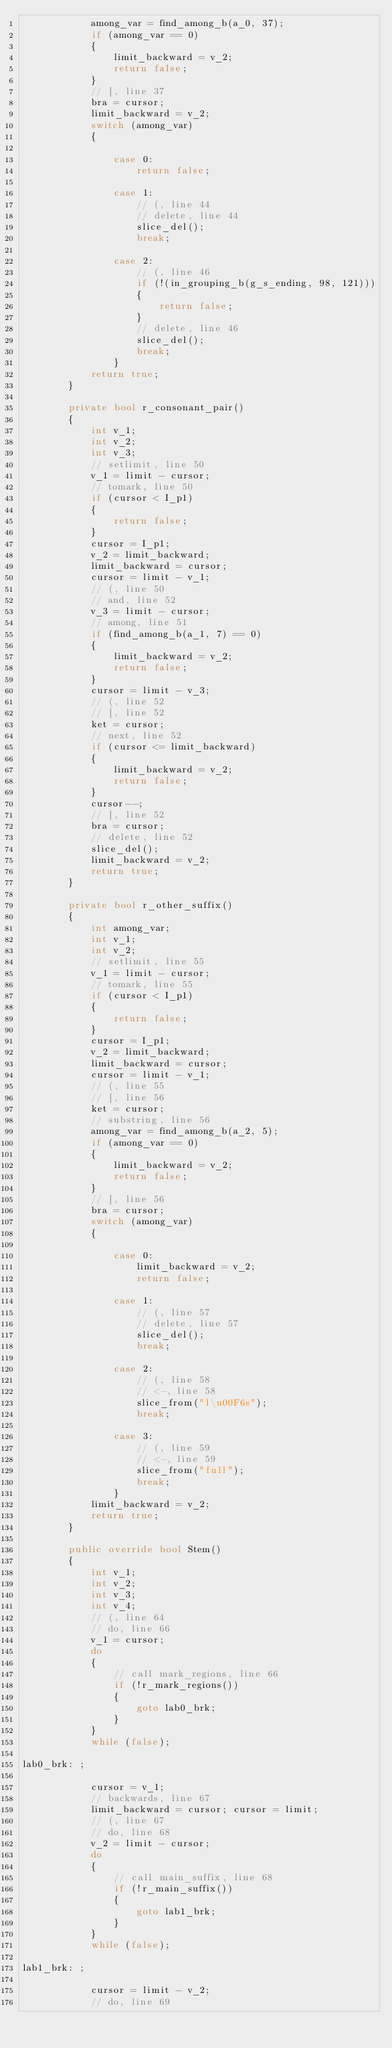Convert code to text. <code><loc_0><loc_0><loc_500><loc_500><_C#_>            among_var = find_among_b(a_0, 37);
            if (among_var == 0)
            {
                limit_backward = v_2;
                return false;
            }
            // ], line 37
            bra = cursor;
            limit_backward = v_2;
            switch (among_var)
            {
                
                case 0: 
                    return false;
                
                case 1: 
                    // (, line 44
                    // delete, line 44
                    slice_del();
                    break;
                
                case 2: 
                    // (, line 46
                    if (!(in_grouping_b(g_s_ending, 98, 121)))
                    {
                        return false;
                    }
                    // delete, line 46
                    slice_del();
                    break;
                }
            return true;
        }
        
        private bool r_consonant_pair()
        {
            int v_1;
            int v_2;
            int v_3;
            // setlimit, line 50
            v_1 = limit - cursor;
            // tomark, line 50
            if (cursor < I_p1)
            {
                return false;
            }
            cursor = I_p1;
            v_2 = limit_backward;
            limit_backward = cursor;
            cursor = limit - v_1;
            // (, line 50
            // and, line 52
            v_3 = limit - cursor;
            // among, line 51
            if (find_among_b(a_1, 7) == 0)
            {
                limit_backward = v_2;
                return false;
            }
            cursor = limit - v_3;
            // (, line 52
            // [, line 52
            ket = cursor;
            // next, line 52
            if (cursor <= limit_backward)
            {
                limit_backward = v_2;
                return false;
            }
            cursor--;
            // ], line 52
            bra = cursor;
            // delete, line 52
            slice_del();
            limit_backward = v_2;
            return true;
        }
        
        private bool r_other_suffix()
        {
            int among_var;
            int v_1;
            int v_2;
            // setlimit, line 55
            v_1 = limit - cursor;
            // tomark, line 55
            if (cursor < I_p1)
            {
                return false;
            }
            cursor = I_p1;
            v_2 = limit_backward;
            limit_backward = cursor;
            cursor = limit - v_1;
            // (, line 55
            // [, line 56
            ket = cursor;
            // substring, line 56
            among_var = find_among_b(a_2, 5);
            if (among_var == 0)
            {
                limit_backward = v_2;
                return false;
            }
            // ], line 56
            bra = cursor;
            switch (among_var)
            {
                
                case 0: 
                    limit_backward = v_2;
                    return false;
                
                case 1: 
                    // (, line 57
                    // delete, line 57
                    slice_del();
                    break;
                
                case 2: 
                    // (, line 58
                    // <-, line 58
                    slice_from("l\u00F6s");
                    break;
                
                case 3: 
                    // (, line 59
                    // <-, line 59
                    slice_from("full");
                    break;
                }
            limit_backward = v_2;
            return true;
        }
        
        public override bool Stem()
        {
            int v_1;
            int v_2;
            int v_3;
            int v_4;
            // (, line 64
            // do, line 66
            v_1 = cursor;
            do 
            {
                // call mark_regions, line 66
                if (!r_mark_regions())
                {
                    goto lab0_brk;
                }
            }
            while (false);

lab0_brk: ;
            
            cursor = v_1;
            // backwards, line 67
            limit_backward = cursor; cursor = limit;
            // (, line 67
            // do, line 68
            v_2 = limit - cursor;
            do 
            {
                // call main_suffix, line 68
                if (!r_main_suffix())
                {
                    goto lab1_brk;
                }
            }
            while (false);

lab1_brk: ;
            
            cursor = limit - v_2;
            // do, line 69</code> 